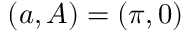<formula> <loc_0><loc_0><loc_500><loc_500>( a , A ) = ( \pi , 0 )</formula> 